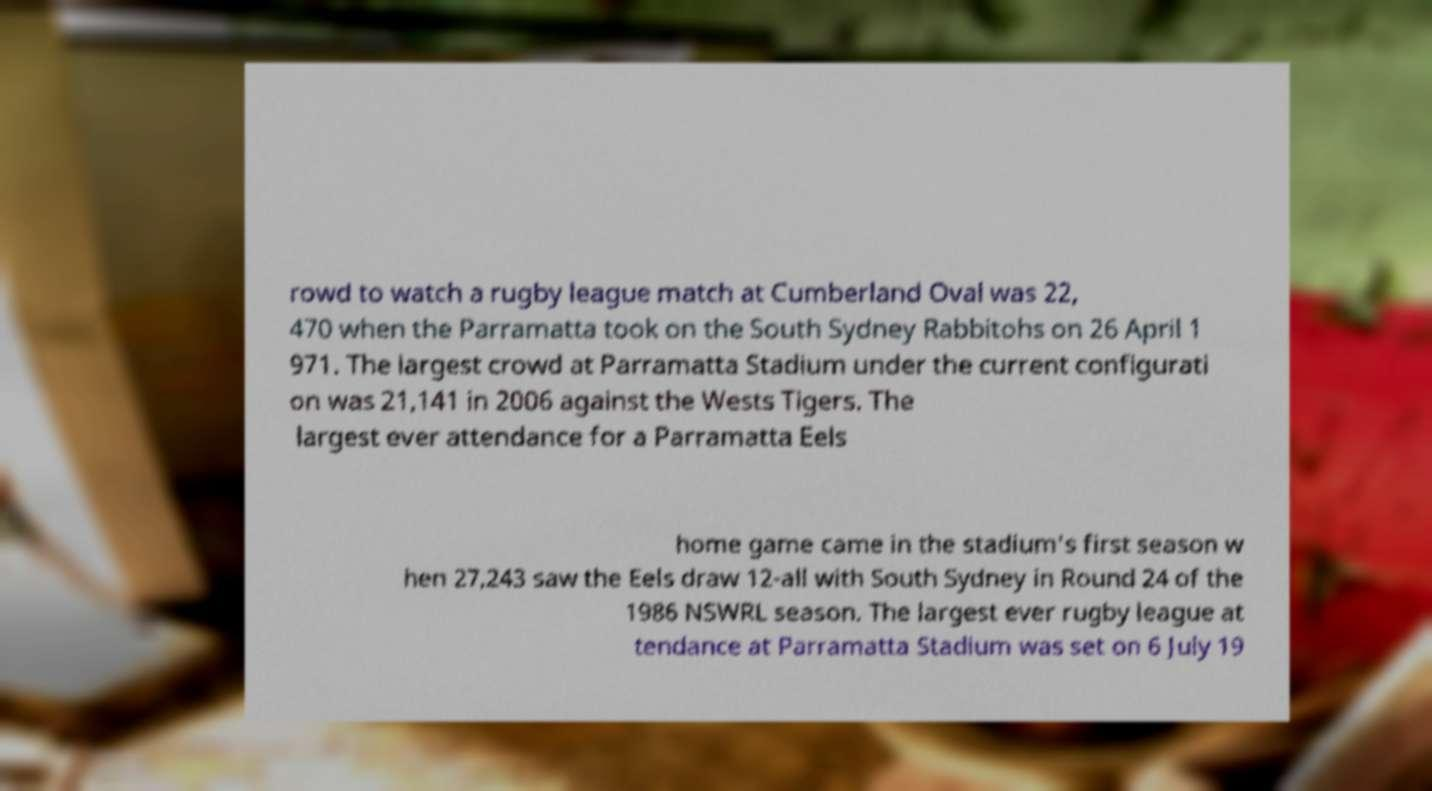For documentation purposes, I need the text within this image transcribed. Could you provide that? rowd to watch a rugby league match at Cumberland Oval was 22, 470 when the Parramatta took on the South Sydney Rabbitohs on 26 April 1 971. The largest crowd at Parramatta Stadium under the current configurati on was 21,141 in 2006 against the Wests Tigers. The largest ever attendance for a Parramatta Eels home game came in the stadium's first season w hen 27,243 saw the Eels draw 12-all with South Sydney in Round 24 of the 1986 NSWRL season. The largest ever rugby league at tendance at Parramatta Stadium was set on 6 July 19 